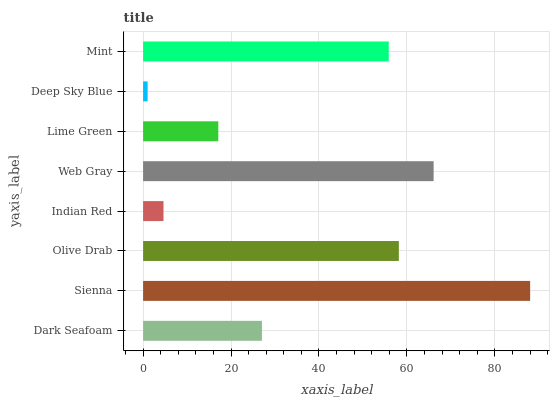Is Deep Sky Blue the minimum?
Answer yes or no. Yes. Is Sienna the maximum?
Answer yes or no. Yes. Is Olive Drab the minimum?
Answer yes or no. No. Is Olive Drab the maximum?
Answer yes or no. No. Is Sienna greater than Olive Drab?
Answer yes or no. Yes. Is Olive Drab less than Sienna?
Answer yes or no. Yes. Is Olive Drab greater than Sienna?
Answer yes or no. No. Is Sienna less than Olive Drab?
Answer yes or no. No. Is Mint the high median?
Answer yes or no. Yes. Is Dark Seafoam the low median?
Answer yes or no. Yes. Is Dark Seafoam the high median?
Answer yes or no. No. Is Web Gray the low median?
Answer yes or no. No. 